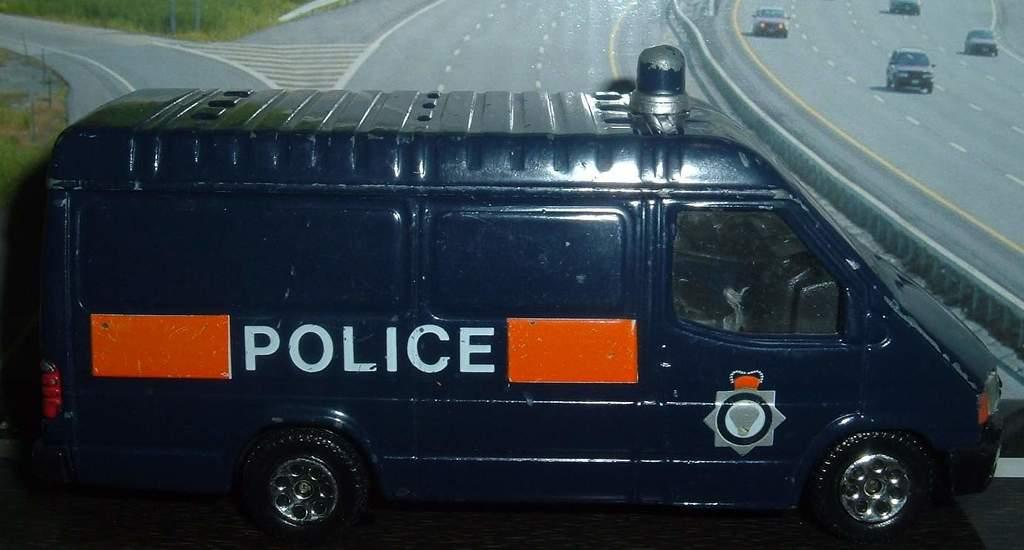What is the main subject of the image? The main subject of the image is a vehicle on the road. Are there any other vehicles visible in the image? Yes, there are other vehicles visible on the road in the image. What type of throat treatment can be seen being administered to the cows in the image? There are no cows or throat treatments present in the image; it features vehicles on a road. 